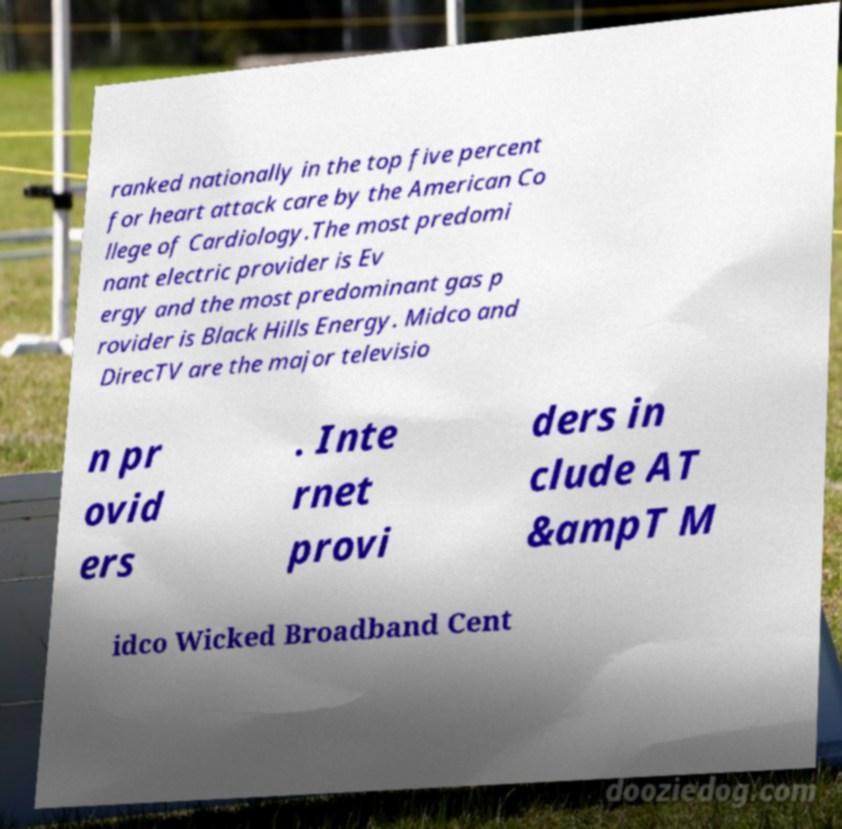I need the written content from this picture converted into text. Can you do that? ranked nationally in the top five percent for heart attack care by the American Co llege of Cardiology.The most predomi nant electric provider is Ev ergy and the most predominant gas p rovider is Black Hills Energy. Midco and DirecTV are the major televisio n pr ovid ers . Inte rnet provi ders in clude AT &ampT M idco Wicked Broadband Cent 